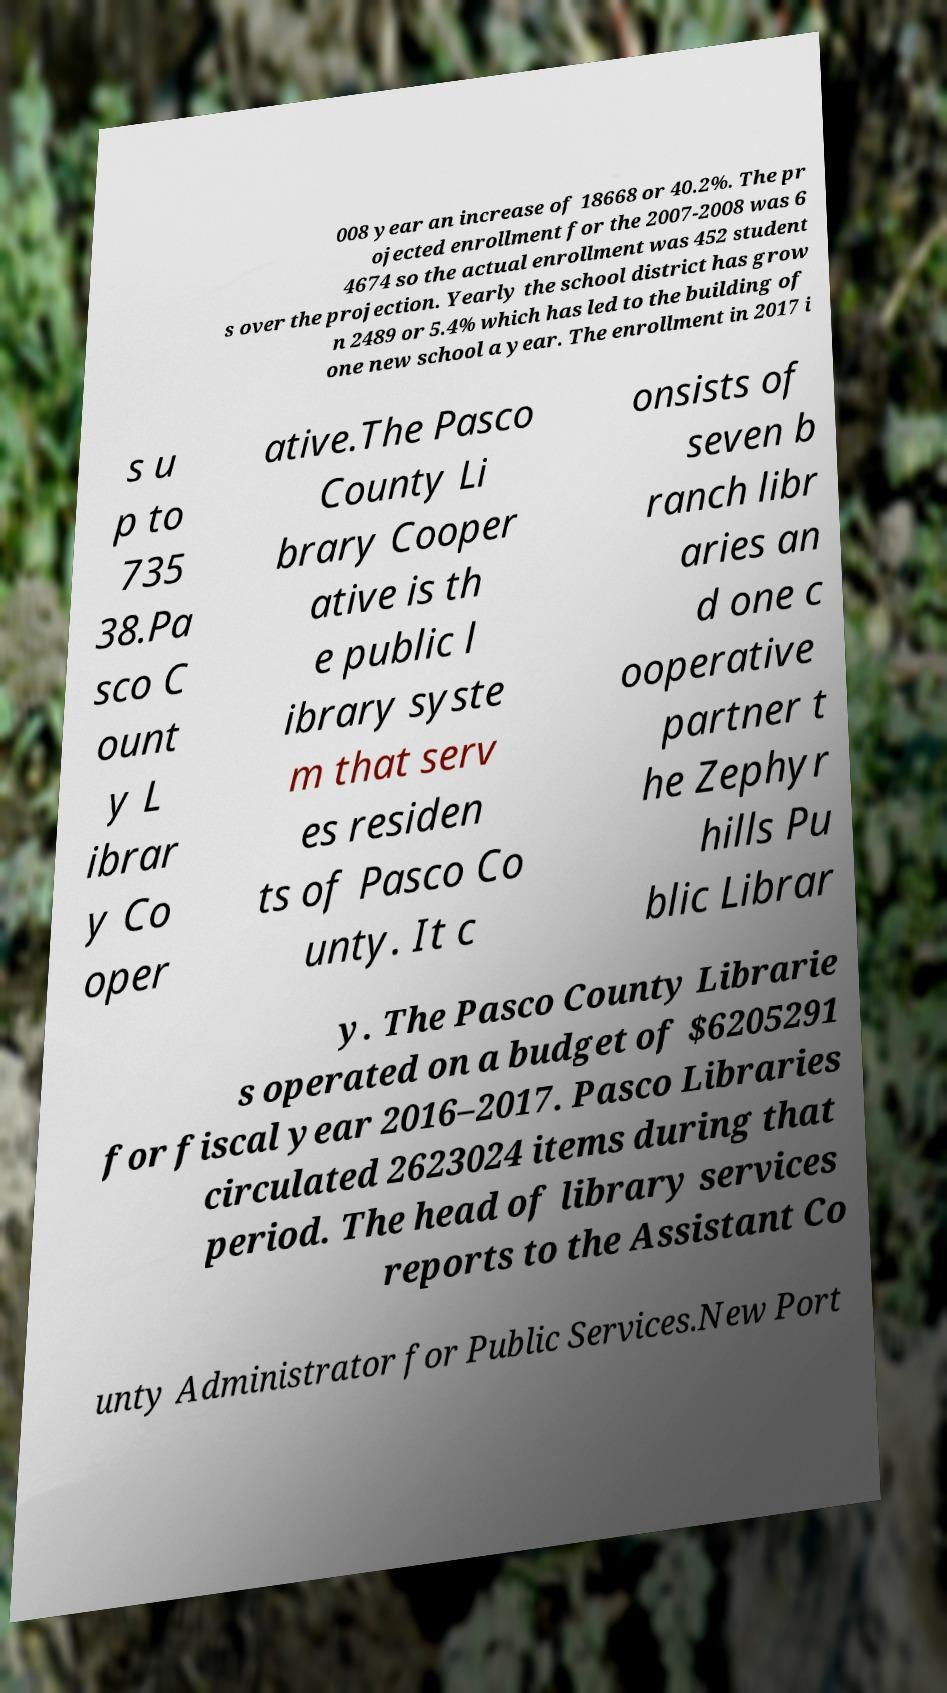There's text embedded in this image that I need extracted. Can you transcribe it verbatim? 008 year an increase of 18668 or 40.2%. The pr ojected enrollment for the 2007-2008 was 6 4674 so the actual enrollment was 452 student s over the projection. Yearly the school district has grow n 2489 or 5.4% which has led to the building of one new school a year. The enrollment in 2017 i s u p to 735 38.Pa sco C ount y L ibrar y Co oper ative.The Pasco County Li brary Cooper ative is th e public l ibrary syste m that serv es residen ts of Pasco Co unty. It c onsists of seven b ranch libr aries an d one c ooperative partner t he Zephyr hills Pu blic Librar y. The Pasco County Librarie s operated on a budget of $6205291 for fiscal year 2016–2017. Pasco Libraries circulated 2623024 items during that period. The head of library services reports to the Assistant Co unty Administrator for Public Services.New Port 